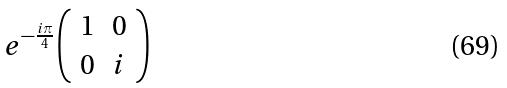<formula> <loc_0><loc_0><loc_500><loc_500>e ^ { - { \frac { i \pi } { 4 } } } { \left ( \begin{array} { l l } { 1 } & { 0 } \\ { 0 } & { i } \end{array} \right ) }</formula> 